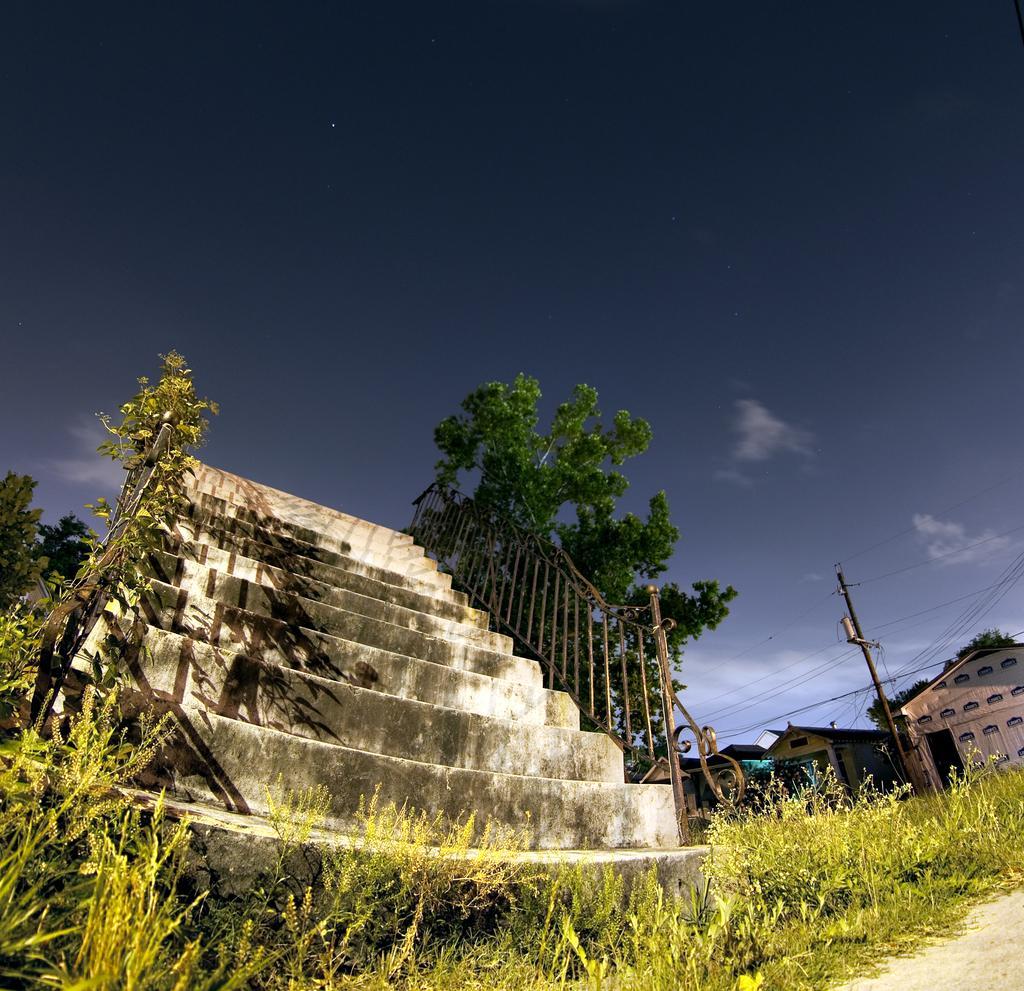Please provide a concise description of this image. In this image I can see few plants which are green in color, the ground, few stairs and the railing. In the background I can see few trees, a pole, few buildings, few wires and the sky. 